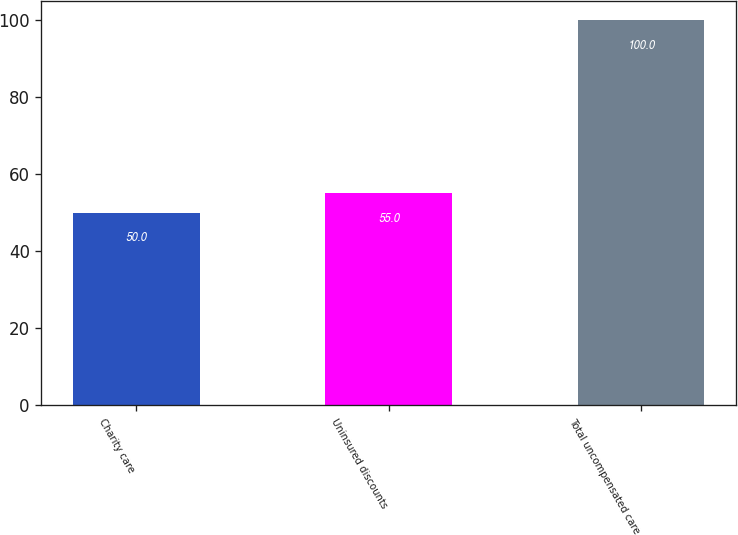Convert chart. <chart><loc_0><loc_0><loc_500><loc_500><bar_chart><fcel>Charity care<fcel>Uninsured discounts<fcel>Total uncompensated care<nl><fcel>50<fcel>55<fcel>100<nl></chart> 